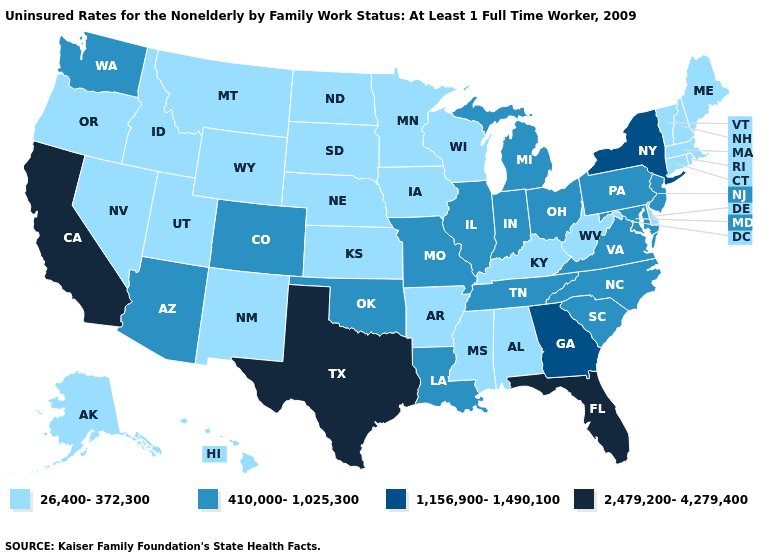Among the states that border New Jersey , does New York have the highest value?
Write a very short answer. Yes. Is the legend a continuous bar?
Short answer required. No. Name the states that have a value in the range 1,156,900-1,490,100?
Keep it brief. Georgia, New York. Name the states that have a value in the range 410,000-1,025,300?
Concise answer only. Arizona, Colorado, Illinois, Indiana, Louisiana, Maryland, Michigan, Missouri, New Jersey, North Carolina, Ohio, Oklahoma, Pennsylvania, South Carolina, Tennessee, Virginia, Washington. Does Michigan have a lower value than Kansas?
Be succinct. No. Is the legend a continuous bar?
Give a very brief answer. No. Among the states that border Virginia , does North Carolina have the lowest value?
Short answer required. No. Does Wyoming have a lower value than Louisiana?
Concise answer only. Yes. Name the states that have a value in the range 410,000-1,025,300?
Write a very short answer. Arizona, Colorado, Illinois, Indiana, Louisiana, Maryland, Michigan, Missouri, New Jersey, North Carolina, Ohio, Oklahoma, Pennsylvania, South Carolina, Tennessee, Virginia, Washington. Which states have the highest value in the USA?
Write a very short answer. California, Florida, Texas. Which states have the highest value in the USA?
Write a very short answer. California, Florida, Texas. What is the value of New Mexico?
Short answer required. 26,400-372,300. Which states hav the highest value in the South?
Give a very brief answer. Florida, Texas. What is the value of Texas?
Short answer required. 2,479,200-4,279,400. Name the states that have a value in the range 410,000-1,025,300?
Answer briefly. Arizona, Colorado, Illinois, Indiana, Louisiana, Maryland, Michigan, Missouri, New Jersey, North Carolina, Ohio, Oklahoma, Pennsylvania, South Carolina, Tennessee, Virginia, Washington. 